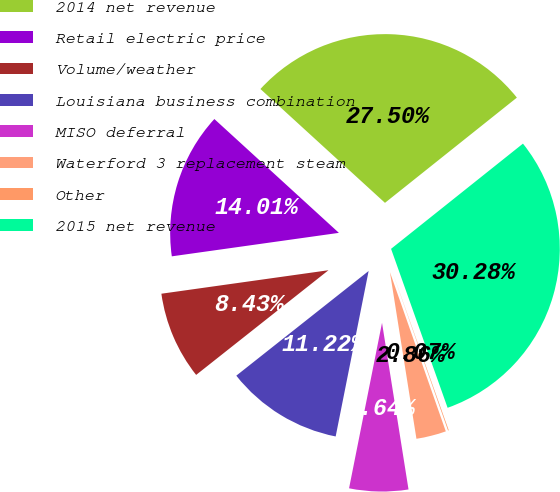<chart> <loc_0><loc_0><loc_500><loc_500><pie_chart><fcel>2014 net revenue<fcel>Retail electric price<fcel>Volume/weather<fcel>Louisiana business combination<fcel>MISO deferral<fcel>Waterford 3 replacement steam<fcel>Other<fcel>2015 net revenue<nl><fcel>27.5%<fcel>14.01%<fcel>8.43%<fcel>11.22%<fcel>5.64%<fcel>2.86%<fcel>0.07%<fcel>30.28%<nl></chart> 